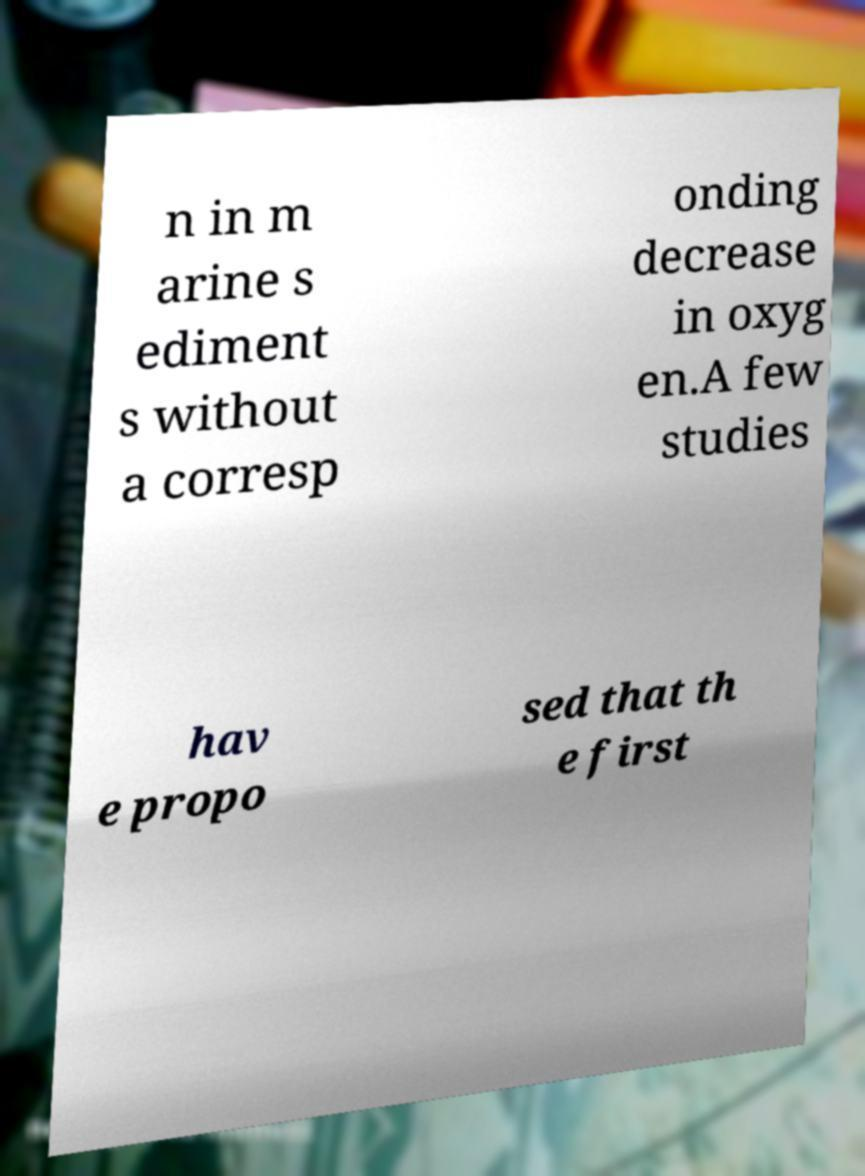What messages or text are displayed in this image? I need them in a readable, typed format. n in m arine s ediment s without a corresp onding decrease in oxyg en.A few studies hav e propo sed that th e first 